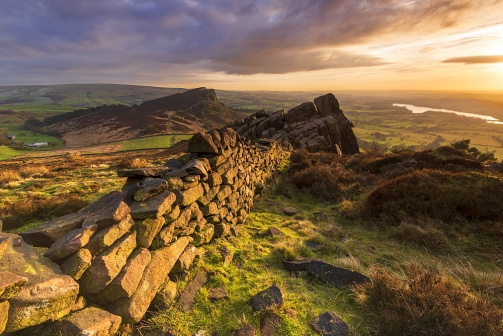Imagine a story about someone discovering this place for the first time. As the first rays of dawn break over the horizon, a weary traveler stumbles upon this hidden valley, overcome by the breathtaking view. They had been wandering for days, searching for solace and a place to find themselves. The stone wall, with its ancient, rugged charm, beckons them closer. Sitting atop the rocky outcrop, the traveler gazes over the tranquil lake and the softly rolling hills, feeling a deep sense of peace and belonging for the first time in years. This quiet sanctuary, embraced by the golden light, becomes a haven where they can reconnect with nature and with themselves. What unique flora and fauna might be found in this landscape? In this serene landscape, one might find delicate wildflowers peeking between the cracks of the stone wall, adding splashes of color to the green surroundings. Hardy grasses and small shrubs, adapted to the rocky terrain, would thrive here. As for fauna, small mammals like rabbits and foxes could be seen darting among the stones. Birds of prey might nest in the rocky outcrop, while waterfowl enjoy the calm lake. Insects, including butterflies and bees, are likely to be busy among the wildflowers, contributing to the biodiversity of this tranquil haven. If this place were magical, what kind of enchantments might it hold? In a land of enchantment, this serene valley might be a hidden refuge of the mystical realm. At sunrise or sunset, when the golden light bathes the landscape, ancient runes etched into the stones of the wall could begin to glow, revealing ancient secrets to those who can decipher them. The lake, with its mirror-like surface, might serve as a portal to another world, accessible only to those who meet the water's guardian spirits. The rocky outcrop could be home to a wise, old dragon who offers wisdom in exchange for tales of the outside world. Every rustle of the grass, every whisper of the breeze, might carry omens or messages from the ethereal beings that protect this enchanted place. Imagine two different periods in time represented in this landscape. Describe them. In ancient times, perhaps this valley was a sacred site for a now-forgotten civilization. The stone wall might have been part of a grand structure, a temple or a fortification, where rituals were performed to honor the gods and nature. The valley, teeming with life, would have been a site of pilgrimage, its lake believed to be imbued with divine properties.

Fast forward to the present day, the wall remains as a silent witness to history, partially reclaimed by nature. The area is a serene, almost mystical retreat, far from the bustle of modern life. It is a place where one can reflect on the passage of time, feeling the presence of those who walked here before, and finding solace in the enduring beauty of the natural world. 